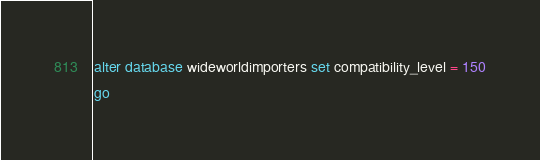<code> <loc_0><loc_0><loc_500><loc_500><_SQL_>alter database wideworldimporters set compatibility_level = 150
go</code> 